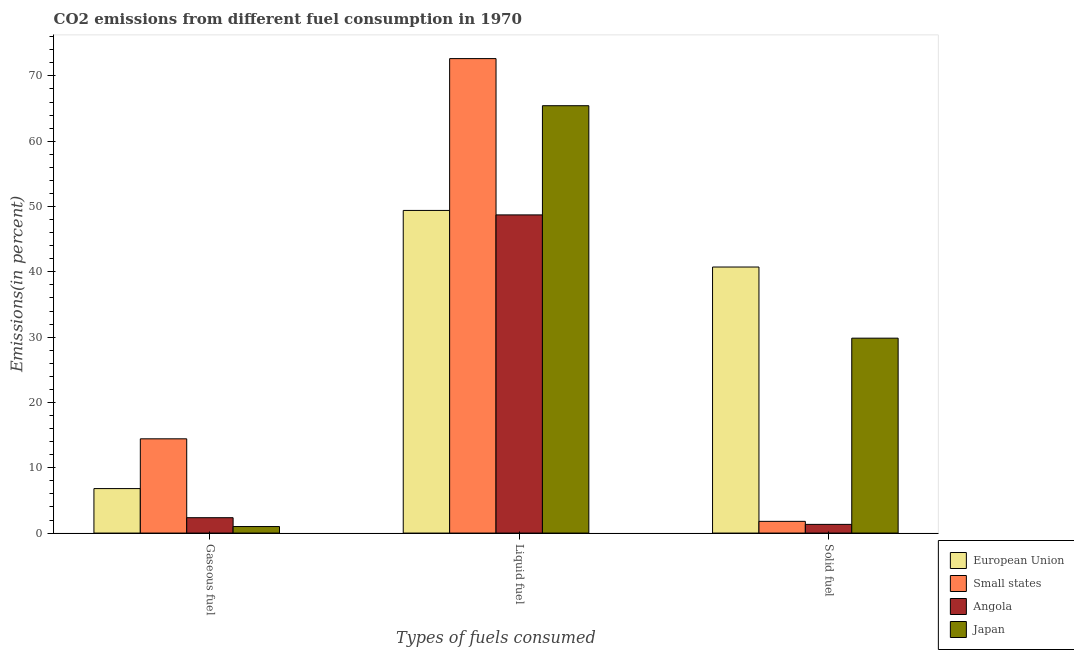How many different coloured bars are there?
Your answer should be very brief. 4. How many groups of bars are there?
Your answer should be compact. 3. Are the number of bars on each tick of the X-axis equal?
Offer a very short reply. Yes. How many bars are there on the 2nd tick from the left?
Offer a very short reply. 4. What is the label of the 1st group of bars from the left?
Keep it short and to the point. Gaseous fuel. What is the percentage of solid fuel emission in Angola?
Ensure brevity in your answer.  1.33. Across all countries, what is the maximum percentage of solid fuel emission?
Your response must be concise. 40.74. Across all countries, what is the minimum percentage of gaseous fuel emission?
Ensure brevity in your answer.  1. In which country was the percentage of gaseous fuel emission maximum?
Provide a short and direct response. Small states. In which country was the percentage of solid fuel emission minimum?
Offer a terse response. Angola. What is the total percentage of liquid fuel emission in the graph?
Provide a short and direct response. 236.22. What is the difference between the percentage of gaseous fuel emission in European Union and that in Small states?
Your answer should be compact. -7.62. What is the difference between the percentage of gaseous fuel emission in European Union and the percentage of liquid fuel emission in Angola?
Your response must be concise. -41.91. What is the average percentage of liquid fuel emission per country?
Your response must be concise. 59.06. What is the difference between the percentage of solid fuel emission and percentage of liquid fuel emission in Japan?
Offer a very short reply. -35.6. What is the ratio of the percentage of solid fuel emission in Small states to that in European Union?
Your response must be concise. 0.04. Is the percentage of gaseous fuel emission in European Union less than that in Angola?
Provide a succinct answer. No. Is the difference between the percentage of solid fuel emission in European Union and Angola greater than the difference between the percentage of gaseous fuel emission in European Union and Angola?
Provide a short and direct response. Yes. What is the difference between the highest and the second highest percentage of gaseous fuel emission?
Provide a short and direct response. 7.62. What is the difference between the highest and the lowest percentage of solid fuel emission?
Offer a very short reply. 39.41. In how many countries, is the percentage of gaseous fuel emission greater than the average percentage of gaseous fuel emission taken over all countries?
Offer a terse response. 2. Is the sum of the percentage of solid fuel emission in Small states and Angola greater than the maximum percentage of liquid fuel emission across all countries?
Provide a short and direct response. No. What does the 3rd bar from the left in Gaseous fuel represents?
Make the answer very short. Angola. Is it the case that in every country, the sum of the percentage of gaseous fuel emission and percentage of liquid fuel emission is greater than the percentage of solid fuel emission?
Your answer should be compact. Yes. How many countries are there in the graph?
Ensure brevity in your answer.  4. Does the graph contain any zero values?
Provide a short and direct response. No. Does the graph contain grids?
Make the answer very short. No. How many legend labels are there?
Provide a succinct answer. 4. What is the title of the graph?
Give a very brief answer. CO2 emissions from different fuel consumption in 1970. Does "Gambia, The" appear as one of the legend labels in the graph?
Give a very brief answer. No. What is the label or title of the X-axis?
Keep it short and to the point. Types of fuels consumed. What is the label or title of the Y-axis?
Offer a very short reply. Emissions(in percent). What is the Emissions(in percent) in European Union in Gaseous fuel?
Provide a short and direct response. 6.81. What is the Emissions(in percent) of Small states in Gaseous fuel?
Ensure brevity in your answer.  14.43. What is the Emissions(in percent) in Angola in Gaseous fuel?
Ensure brevity in your answer.  2.35. What is the Emissions(in percent) of Japan in Gaseous fuel?
Provide a succinct answer. 1. What is the Emissions(in percent) in European Union in Liquid fuel?
Your answer should be very brief. 49.41. What is the Emissions(in percent) of Small states in Liquid fuel?
Provide a short and direct response. 72.65. What is the Emissions(in percent) in Angola in Liquid fuel?
Provide a succinct answer. 48.72. What is the Emissions(in percent) of Japan in Liquid fuel?
Offer a very short reply. 65.44. What is the Emissions(in percent) in European Union in Solid fuel?
Ensure brevity in your answer.  40.74. What is the Emissions(in percent) of Small states in Solid fuel?
Your answer should be very brief. 1.79. What is the Emissions(in percent) of Angola in Solid fuel?
Make the answer very short. 1.33. What is the Emissions(in percent) of Japan in Solid fuel?
Your response must be concise. 29.84. Across all Types of fuels consumed, what is the maximum Emissions(in percent) of European Union?
Offer a very short reply. 49.41. Across all Types of fuels consumed, what is the maximum Emissions(in percent) in Small states?
Give a very brief answer. 72.65. Across all Types of fuels consumed, what is the maximum Emissions(in percent) of Angola?
Your answer should be very brief. 48.72. Across all Types of fuels consumed, what is the maximum Emissions(in percent) in Japan?
Your response must be concise. 65.44. Across all Types of fuels consumed, what is the minimum Emissions(in percent) of European Union?
Provide a short and direct response. 6.81. Across all Types of fuels consumed, what is the minimum Emissions(in percent) in Small states?
Give a very brief answer. 1.79. Across all Types of fuels consumed, what is the minimum Emissions(in percent) in Angola?
Your response must be concise. 1.33. Across all Types of fuels consumed, what is the minimum Emissions(in percent) of Japan?
Your answer should be compact. 1. What is the total Emissions(in percent) in European Union in the graph?
Give a very brief answer. 96.96. What is the total Emissions(in percent) in Small states in the graph?
Provide a succinct answer. 88.88. What is the total Emissions(in percent) in Angola in the graph?
Offer a very short reply. 52.41. What is the total Emissions(in percent) of Japan in the graph?
Provide a succinct answer. 96.28. What is the difference between the Emissions(in percent) of European Union in Gaseous fuel and that in Liquid fuel?
Provide a succinct answer. -42.59. What is the difference between the Emissions(in percent) of Small states in Gaseous fuel and that in Liquid fuel?
Ensure brevity in your answer.  -58.22. What is the difference between the Emissions(in percent) of Angola in Gaseous fuel and that in Liquid fuel?
Your response must be concise. -46.37. What is the difference between the Emissions(in percent) in Japan in Gaseous fuel and that in Liquid fuel?
Your answer should be very brief. -64.44. What is the difference between the Emissions(in percent) of European Union in Gaseous fuel and that in Solid fuel?
Provide a succinct answer. -33.93. What is the difference between the Emissions(in percent) in Small states in Gaseous fuel and that in Solid fuel?
Your answer should be very brief. 12.64. What is the difference between the Emissions(in percent) in Angola in Gaseous fuel and that in Solid fuel?
Provide a succinct answer. 1.02. What is the difference between the Emissions(in percent) in Japan in Gaseous fuel and that in Solid fuel?
Offer a very short reply. -28.85. What is the difference between the Emissions(in percent) in European Union in Liquid fuel and that in Solid fuel?
Make the answer very short. 8.67. What is the difference between the Emissions(in percent) of Small states in Liquid fuel and that in Solid fuel?
Ensure brevity in your answer.  70.86. What is the difference between the Emissions(in percent) of Angola in Liquid fuel and that in Solid fuel?
Your answer should be very brief. 47.39. What is the difference between the Emissions(in percent) in Japan in Liquid fuel and that in Solid fuel?
Offer a very short reply. 35.6. What is the difference between the Emissions(in percent) of European Union in Gaseous fuel and the Emissions(in percent) of Small states in Liquid fuel?
Your answer should be compact. -65.84. What is the difference between the Emissions(in percent) of European Union in Gaseous fuel and the Emissions(in percent) of Angola in Liquid fuel?
Make the answer very short. -41.91. What is the difference between the Emissions(in percent) in European Union in Gaseous fuel and the Emissions(in percent) in Japan in Liquid fuel?
Offer a terse response. -58.63. What is the difference between the Emissions(in percent) in Small states in Gaseous fuel and the Emissions(in percent) in Angola in Liquid fuel?
Provide a succinct answer. -34.29. What is the difference between the Emissions(in percent) of Small states in Gaseous fuel and the Emissions(in percent) of Japan in Liquid fuel?
Keep it short and to the point. -51.01. What is the difference between the Emissions(in percent) of Angola in Gaseous fuel and the Emissions(in percent) of Japan in Liquid fuel?
Your answer should be compact. -63.09. What is the difference between the Emissions(in percent) in European Union in Gaseous fuel and the Emissions(in percent) in Small states in Solid fuel?
Your response must be concise. 5.02. What is the difference between the Emissions(in percent) of European Union in Gaseous fuel and the Emissions(in percent) of Angola in Solid fuel?
Keep it short and to the point. 5.48. What is the difference between the Emissions(in percent) in European Union in Gaseous fuel and the Emissions(in percent) in Japan in Solid fuel?
Make the answer very short. -23.03. What is the difference between the Emissions(in percent) in Small states in Gaseous fuel and the Emissions(in percent) in Angola in Solid fuel?
Your answer should be compact. 13.1. What is the difference between the Emissions(in percent) of Small states in Gaseous fuel and the Emissions(in percent) of Japan in Solid fuel?
Offer a terse response. -15.41. What is the difference between the Emissions(in percent) in Angola in Gaseous fuel and the Emissions(in percent) in Japan in Solid fuel?
Your answer should be compact. -27.49. What is the difference between the Emissions(in percent) in European Union in Liquid fuel and the Emissions(in percent) in Small states in Solid fuel?
Provide a succinct answer. 47.61. What is the difference between the Emissions(in percent) in European Union in Liquid fuel and the Emissions(in percent) in Angola in Solid fuel?
Ensure brevity in your answer.  48.07. What is the difference between the Emissions(in percent) in European Union in Liquid fuel and the Emissions(in percent) in Japan in Solid fuel?
Your answer should be compact. 19.56. What is the difference between the Emissions(in percent) in Small states in Liquid fuel and the Emissions(in percent) in Angola in Solid fuel?
Provide a succinct answer. 71.32. What is the difference between the Emissions(in percent) in Small states in Liquid fuel and the Emissions(in percent) in Japan in Solid fuel?
Offer a very short reply. 42.81. What is the difference between the Emissions(in percent) in Angola in Liquid fuel and the Emissions(in percent) in Japan in Solid fuel?
Offer a terse response. 18.88. What is the average Emissions(in percent) of European Union per Types of fuels consumed?
Offer a terse response. 32.32. What is the average Emissions(in percent) in Small states per Types of fuels consumed?
Provide a succinct answer. 29.63. What is the average Emissions(in percent) in Angola per Types of fuels consumed?
Provide a short and direct response. 17.47. What is the average Emissions(in percent) of Japan per Types of fuels consumed?
Your answer should be very brief. 32.09. What is the difference between the Emissions(in percent) in European Union and Emissions(in percent) in Small states in Gaseous fuel?
Your answer should be compact. -7.62. What is the difference between the Emissions(in percent) of European Union and Emissions(in percent) of Angola in Gaseous fuel?
Offer a very short reply. 4.46. What is the difference between the Emissions(in percent) of European Union and Emissions(in percent) of Japan in Gaseous fuel?
Provide a succinct answer. 5.81. What is the difference between the Emissions(in percent) in Small states and Emissions(in percent) in Angola in Gaseous fuel?
Provide a succinct answer. 12.08. What is the difference between the Emissions(in percent) of Small states and Emissions(in percent) of Japan in Gaseous fuel?
Make the answer very short. 13.43. What is the difference between the Emissions(in percent) of Angola and Emissions(in percent) of Japan in Gaseous fuel?
Provide a succinct answer. 1.35. What is the difference between the Emissions(in percent) in European Union and Emissions(in percent) in Small states in Liquid fuel?
Make the answer very short. -23.25. What is the difference between the Emissions(in percent) in European Union and Emissions(in percent) in Angola in Liquid fuel?
Your answer should be compact. 0.68. What is the difference between the Emissions(in percent) in European Union and Emissions(in percent) in Japan in Liquid fuel?
Your answer should be very brief. -16.04. What is the difference between the Emissions(in percent) in Small states and Emissions(in percent) in Angola in Liquid fuel?
Provide a succinct answer. 23.93. What is the difference between the Emissions(in percent) in Small states and Emissions(in percent) in Japan in Liquid fuel?
Give a very brief answer. 7.21. What is the difference between the Emissions(in percent) in Angola and Emissions(in percent) in Japan in Liquid fuel?
Your answer should be very brief. -16.72. What is the difference between the Emissions(in percent) in European Union and Emissions(in percent) in Small states in Solid fuel?
Make the answer very short. 38.94. What is the difference between the Emissions(in percent) in European Union and Emissions(in percent) in Angola in Solid fuel?
Make the answer very short. 39.41. What is the difference between the Emissions(in percent) of European Union and Emissions(in percent) of Japan in Solid fuel?
Offer a terse response. 10.89. What is the difference between the Emissions(in percent) of Small states and Emissions(in percent) of Angola in Solid fuel?
Provide a succinct answer. 0.46. What is the difference between the Emissions(in percent) in Small states and Emissions(in percent) in Japan in Solid fuel?
Your response must be concise. -28.05. What is the difference between the Emissions(in percent) of Angola and Emissions(in percent) of Japan in Solid fuel?
Provide a short and direct response. -28.51. What is the ratio of the Emissions(in percent) in European Union in Gaseous fuel to that in Liquid fuel?
Ensure brevity in your answer.  0.14. What is the ratio of the Emissions(in percent) in Small states in Gaseous fuel to that in Liquid fuel?
Your answer should be very brief. 0.2. What is the ratio of the Emissions(in percent) in Angola in Gaseous fuel to that in Liquid fuel?
Give a very brief answer. 0.05. What is the ratio of the Emissions(in percent) in Japan in Gaseous fuel to that in Liquid fuel?
Provide a short and direct response. 0.02. What is the ratio of the Emissions(in percent) in European Union in Gaseous fuel to that in Solid fuel?
Provide a short and direct response. 0.17. What is the ratio of the Emissions(in percent) of Small states in Gaseous fuel to that in Solid fuel?
Make the answer very short. 8.04. What is the ratio of the Emissions(in percent) of Angola in Gaseous fuel to that in Solid fuel?
Your answer should be compact. 1.77. What is the ratio of the Emissions(in percent) of Japan in Gaseous fuel to that in Solid fuel?
Offer a very short reply. 0.03. What is the ratio of the Emissions(in percent) of European Union in Liquid fuel to that in Solid fuel?
Your answer should be compact. 1.21. What is the ratio of the Emissions(in percent) of Small states in Liquid fuel to that in Solid fuel?
Give a very brief answer. 40.48. What is the ratio of the Emissions(in percent) of Angola in Liquid fuel to that in Solid fuel?
Make the answer very short. 36.62. What is the ratio of the Emissions(in percent) in Japan in Liquid fuel to that in Solid fuel?
Provide a succinct answer. 2.19. What is the difference between the highest and the second highest Emissions(in percent) in European Union?
Provide a succinct answer. 8.67. What is the difference between the highest and the second highest Emissions(in percent) of Small states?
Provide a succinct answer. 58.22. What is the difference between the highest and the second highest Emissions(in percent) in Angola?
Offer a terse response. 46.37. What is the difference between the highest and the second highest Emissions(in percent) in Japan?
Provide a succinct answer. 35.6. What is the difference between the highest and the lowest Emissions(in percent) in European Union?
Your answer should be compact. 42.59. What is the difference between the highest and the lowest Emissions(in percent) of Small states?
Your response must be concise. 70.86. What is the difference between the highest and the lowest Emissions(in percent) in Angola?
Your response must be concise. 47.39. What is the difference between the highest and the lowest Emissions(in percent) in Japan?
Your response must be concise. 64.44. 